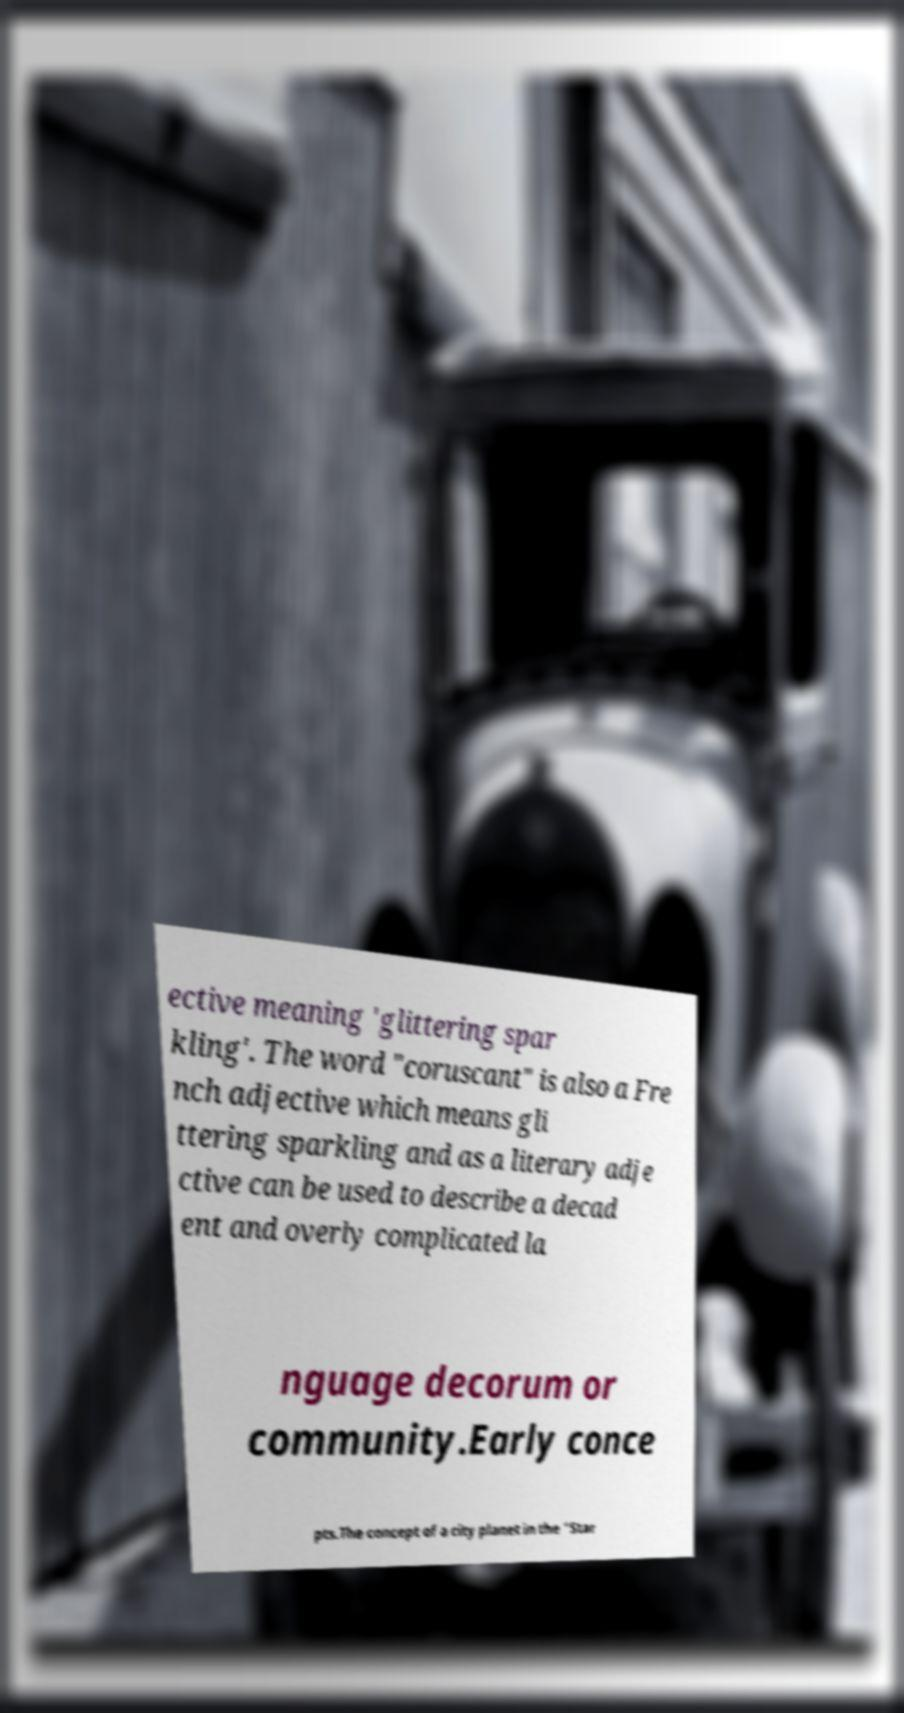I need the written content from this picture converted into text. Can you do that? ective meaning 'glittering spar kling'. The word "coruscant" is also a Fre nch adjective which means gli ttering sparkling and as a literary adje ctive can be used to describe a decad ent and overly complicated la nguage decorum or community.Early conce pts.The concept of a city planet in the "Star 